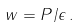<formula> <loc_0><loc_0><loc_500><loc_500>w = P / \epsilon \, .</formula> 